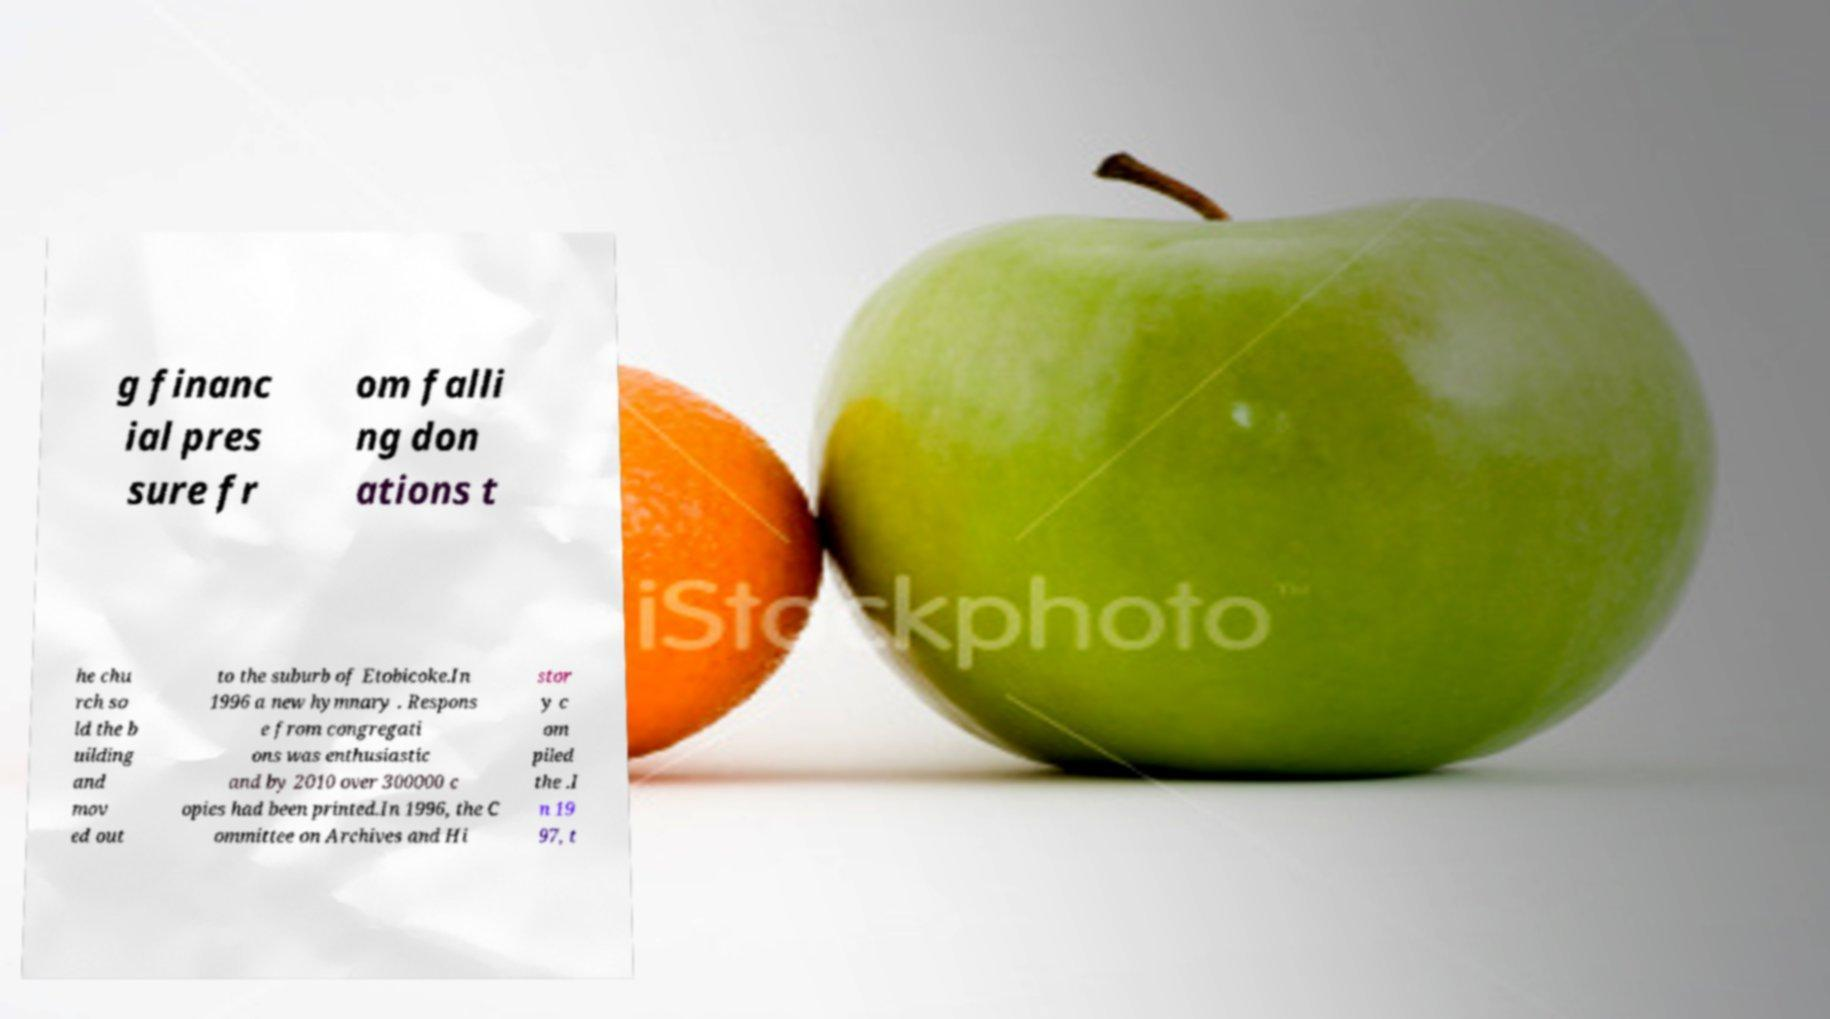Could you extract and type out the text from this image? g financ ial pres sure fr om falli ng don ations t he chu rch so ld the b uilding and mov ed out to the suburb of Etobicoke.In 1996 a new hymnary . Respons e from congregati ons was enthusiastic and by 2010 over 300000 c opies had been printed.In 1996, the C ommittee on Archives and Hi stor y c om piled the .I n 19 97, t 